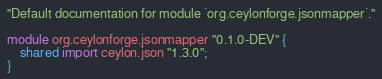<code> <loc_0><loc_0><loc_500><loc_500><_Ceylon_>"Default documentation for module `org.ceylonforge.jsonmapper`."

module org.ceylonforge.jsonmapper "0.1.0-DEV" {
    shared import ceylon.json "1.3.0";
}
</code> 